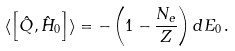<formula> <loc_0><loc_0><loc_500><loc_500>\langle \left [ \hat { Q } , \hat { H } _ { 0 } \right ] \rangle = - \left ( 1 - \frac { N _ { e } } { Z } \right ) { d } { E } _ { 0 } \, .</formula> 